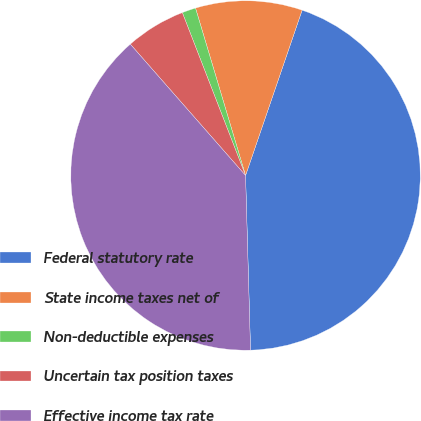Convert chart to OTSL. <chart><loc_0><loc_0><loc_500><loc_500><pie_chart><fcel>Federal statutory rate<fcel>State income taxes net of<fcel>Non-deductible expenses<fcel>Uncertain tax position taxes<fcel>Effective income tax rate<nl><fcel>44.3%<fcel>9.87%<fcel>1.27%<fcel>5.57%<fcel>38.99%<nl></chart> 